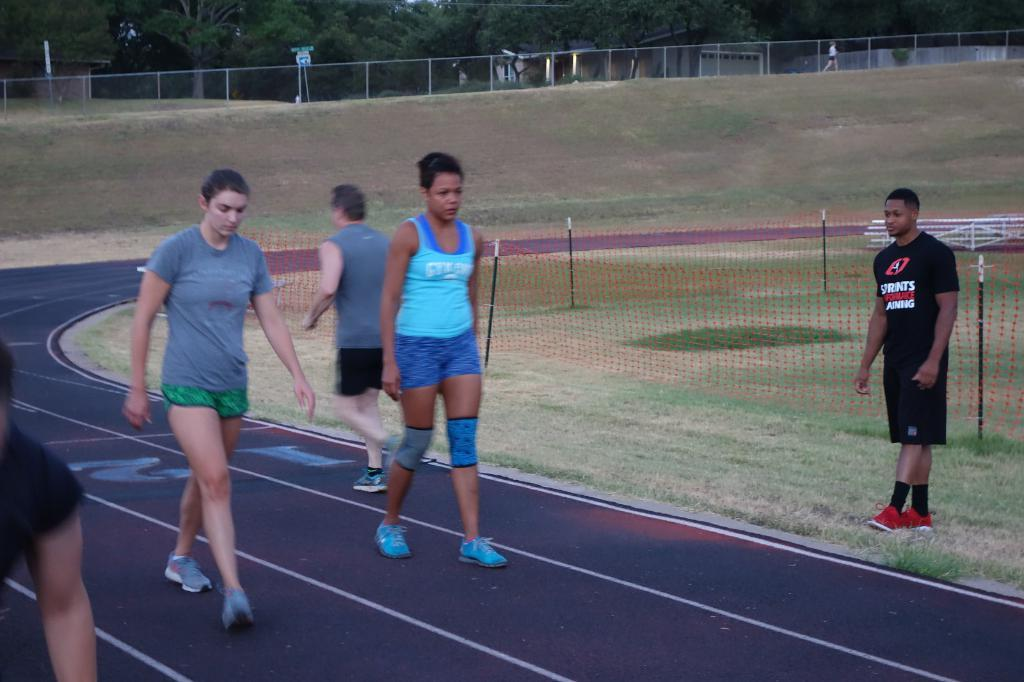What are the people in the image doing? The people in the image are walking. Can you describe the clothing of one of the people? One person is wearing a blue dress. What can be seen in the background of the image? There is fencing and trees with green color in the background of the image. What type of circle can be seen in the stomach of the person wearing the blue dress? There is no circle visible in the stomach of the person wearing the blue dress in the image. 